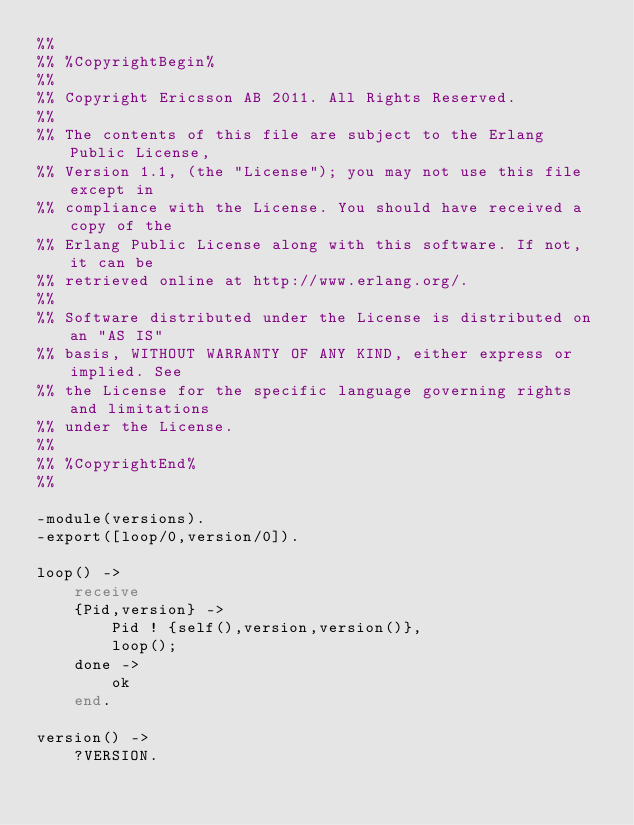<code> <loc_0><loc_0><loc_500><loc_500><_Erlang_>%%
%% %CopyrightBegin%
%%
%% Copyright Ericsson AB 2011. All Rights Reserved.
%%
%% The contents of this file are subject to the Erlang Public License,
%% Version 1.1, (the "License"); you may not use this file except in
%% compliance with the License. You should have received a copy of the
%% Erlang Public License along with this software. If not, it can be
%% retrieved online at http://www.erlang.org/.
%%
%% Software distributed under the License is distributed on an "AS IS"
%% basis, WITHOUT WARRANTY OF ANY KIND, either express or implied. See
%% the License for the specific language governing rights and limitations
%% under the License.
%%
%% %CopyrightEnd%
%%

-module(versions).
-export([loop/0,version/0]).

loop() ->
    receive
	{Pid,version} ->
	    Pid ! {self(),version,version()},
	    loop();
	done ->
	    ok
    end.

version() ->
    ?VERSION.
</code> 